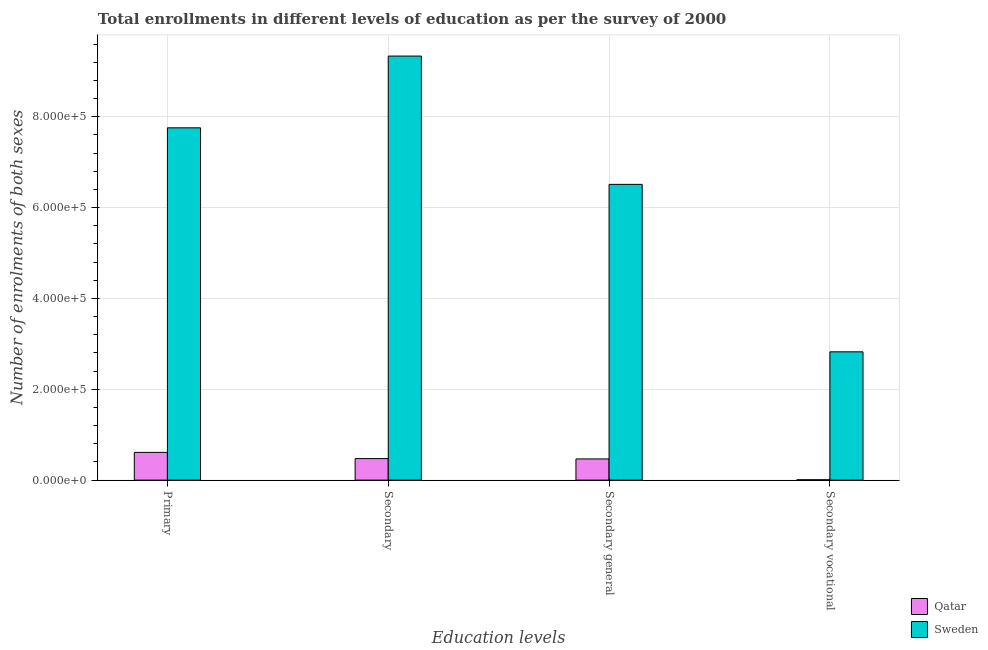How many different coloured bars are there?
Your response must be concise. 2. How many bars are there on the 4th tick from the left?
Give a very brief answer. 2. What is the label of the 2nd group of bars from the left?
Give a very brief answer. Secondary. What is the number of enrolments in primary education in Qatar?
Provide a short and direct response. 6.11e+04. Across all countries, what is the maximum number of enrolments in secondary vocational education?
Your answer should be compact. 2.82e+05. Across all countries, what is the minimum number of enrolments in secondary education?
Your answer should be very brief. 4.74e+04. In which country was the number of enrolments in secondary vocational education maximum?
Your response must be concise. Sweden. In which country was the number of enrolments in primary education minimum?
Offer a very short reply. Qatar. What is the total number of enrolments in secondary general education in the graph?
Your answer should be compact. 6.98e+05. What is the difference between the number of enrolments in primary education in Qatar and that in Sweden?
Provide a succinct answer. -7.15e+05. What is the difference between the number of enrolments in secondary education in Qatar and the number of enrolments in secondary general education in Sweden?
Make the answer very short. -6.04e+05. What is the average number of enrolments in secondary general education per country?
Provide a succinct answer. 3.49e+05. What is the difference between the number of enrolments in secondary vocational education and number of enrolments in primary education in Sweden?
Your answer should be very brief. -4.93e+05. What is the ratio of the number of enrolments in secondary vocational education in Sweden to that in Qatar?
Make the answer very short. 371.68. Is the number of enrolments in primary education in Sweden less than that in Qatar?
Your response must be concise. No. Is the difference between the number of enrolments in secondary vocational education in Qatar and Sweden greater than the difference between the number of enrolments in primary education in Qatar and Sweden?
Your answer should be compact. Yes. What is the difference between the highest and the second highest number of enrolments in primary education?
Provide a succinct answer. 7.15e+05. What is the difference between the highest and the lowest number of enrolments in secondary general education?
Offer a terse response. 6.05e+05. Is it the case that in every country, the sum of the number of enrolments in primary education and number of enrolments in secondary education is greater than the number of enrolments in secondary general education?
Ensure brevity in your answer.  Yes. Are all the bars in the graph horizontal?
Make the answer very short. No. What is the difference between two consecutive major ticks on the Y-axis?
Your answer should be very brief. 2.00e+05. Does the graph contain grids?
Your response must be concise. Yes. How many legend labels are there?
Offer a terse response. 2. How are the legend labels stacked?
Ensure brevity in your answer.  Vertical. What is the title of the graph?
Provide a succinct answer. Total enrollments in different levels of education as per the survey of 2000. Does "Caribbean small states" appear as one of the legend labels in the graph?
Your answer should be very brief. No. What is the label or title of the X-axis?
Keep it short and to the point. Education levels. What is the label or title of the Y-axis?
Give a very brief answer. Number of enrolments of both sexes. What is the Number of enrolments of both sexes in Qatar in Primary?
Your answer should be compact. 6.11e+04. What is the Number of enrolments of both sexes of Sweden in Primary?
Provide a short and direct response. 7.76e+05. What is the Number of enrolments of both sexes in Qatar in Secondary?
Offer a very short reply. 4.74e+04. What is the Number of enrolments of both sexes of Sweden in Secondary?
Your answer should be compact. 9.34e+05. What is the Number of enrolments of both sexes of Qatar in Secondary general?
Provide a short and direct response. 4.67e+04. What is the Number of enrolments of both sexes of Sweden in Secondary general?
Give a very brief answer. 6.51e+05. What is the Number of enrolments of both sexes of Qatar in Secondary vocational?
Offer a very short reply. 760. What is the Number of enrolments of both sexes of Sweden in Secondary vocational?
Keep it short and to the point. 2.82e+05. Across all Education levels, what is the maximum Number of enrolments of both sexes of Qatar?
Ensure brevity in your answer.  6.11e+04. Across all Education levels, what is the maximum Number of enrolments of both sexes in Sweden?
Your answer should be very brief. 9.34e+05. Across all Education levels, what is the minimum Number of enrolments of both sexes in Qatar?
Your response must be concise. 760. Across all Education levels, what is the minimum Number of enrolments of both sexes in Sweden?
Provide a succinct answer. 2.82e+05. What is the total Number of enrolments of both sexes in Qatar in the graph?
Provide a succinct answer. 1.56e+05. What is the total Number of enrolments of both sexes in Sweden in the graph?
Provide a short and direct response. 2.64e+06. What is the difference between the Number of enrolments of both sexes in Qatar in Primary and that in Secondary?
Your answer should be very brief. 1.37e+04. What is the difference between the Number of enrolments of both sexes in Sweden in Primary and that in Secondary?
Make the answer very short. -1.58e+05. What is the difference between the Number of enrolments of both sexes of Qatar in Primary and that in Secondary general?
Make the answer very short. 1.44e+04. What is the difference between the Number of enrolments of both sexes in Sweden in Primary and that in Secondary general?
Offer a very short reply. 1.25e+05. What is the difference between the Number of enrolments of both sexes in Qatar in Primary and that in Secondary vocational?
Provide a succinct answer. 6.03e+04. What is the difference between the Number of enrolments of both sexes in Sweden in Primary and that in Secondary vocational?
Keep it short and to the point. 4.93e+05. What is the difference between the Number of enrolments of both sexes of Qatar in Secondary and that in Secondary general?
Provide a short and direct response. 760. What is the difference between the Number of enrolments of both sexes of Sweden in Secondary and that in Secondary general?
Your response must be concise. 2.82e+05. What is the difference between the Number of enrolments of both sexes in Qatar in Secondary and that in Secondary vocational?
Keep it short and to the point. 4.67e+04. What is the difference between the Number of enrolments of both sexes in Sweden in Secondary and that in Secondary vocational?
Provide a succinct answer. 6.51e+05. What is the difference between the Number of enrolments of both sexes in Qatar in Secondary general and that in Secondary vocational?
Ensure brevity in your answer.  4.59e+04. What is the difference between the Number of enrolments of both sexes of Sweden in Secondary general and that in Secondary vocational?
Provide a succinct answer. 3.69e+05. What is the difference between the Number of enrolments of both sexes in Qatar in Primary and the Number of enrolments of both sexes in Sweden in Secondary?
Provide a succinct answer. -8.73e+05. What is the difference between the Number of enrolments of both sexes of Qatar in Primary and the Number of enrolments of both sexes of Sweden in Secondary general?
Your response must be concise. -5.90e+05. What is the difference between the Number of enrolments of both sexes in Qatar in Primary and the Number of enrolments of both sexes in Sweden in Secondary vocational?
Offer a very short reply. -2.21e+05. What is the difference between the Number of enrolments of both sexes of Qatar in Secondary and the Number of enrolments of both sexes of Sweden in Secondary general?
Your response must be concise. -6.04e+05. What is the difference between the Number of enrolments of both sexes in Qatar in Secondary and the Number of enrolments of both sexes in Sweden in Secondary vocational?
Provide a succinct answer. -2.35e+05. What is the difference between the Number of enrolments of both sexes of Qatar in Secondary general and the Number of enrolments of both sexes of Sweden in Secondary vocational?
Give a very brief answer. -2.36e+05. What is the average Number of enrolments of both sexes in Qatar per Education levels?
Ensure brevity in your answer.  3.90e+04. What is the average Number of enrolments of both sexes of Sweden per Education levels?
Provide a succinct answer. 6.61e+05. What is the difference between the Number of enrolments of both sexes in Qatar and Number of enrolments of both sexes in Sweden in Primary?
Your answer should be very brief. -7.15e+05. What is the difference between the Number of enrolments of both sexes in Qatar and Number of enrolments of both sexes in Sweden in Secondary?
Provide a succinct answer. -8.86e+05. What is the difference between the Number of enrolments of both sexes of Qatar and Number of enrolments of both sexes of Sweden in Secondary general?
Offer a very short reply. -6.05e+05. What is the difference between the Number of enrolments of both sexes in Qatar and Number of enrolments of both sexes in Sweden in Secondary vocational?
Offer a very short reply. -2.82e+05. What is the ratio of the Number of enrolments of both sexes in Qatar in Primary to that in Secondary?
Your answer should be compact. 1.29. What is the ratio of the Number of enrolments of both sexes in Sweden in Primary to that in Secondary?
Your answer should be compact. 0.83. What is the ratio of the Number of enrolments of both sexes in Qatar in Primary to that in Secondary general?
Your answer should be very brief. 1.31. What is the ratio of the Number of enrolments of both sexes of Sweden in Primary to that in Secondary general?
Your response must be concise. 1.19. What is the ratio of the Number of enrolments of both sexes in Qatar in Primary to that in Secondary vocational?
Offer a very short reply. 80.35. What is the ratio of the Number of enrolments of both sexes in Sweden in Primary to that in Secondary vocational?
Give a very brief answer. 2.75. What is the ratio of the Number of enrolments of both sexes in Qatar in Secondary to that in Secondary general?
Offer a terse response. 1.02. What is the ratio of the Number of enrolments of both sexes in Sweden in Secondary to that in Secondary general?
Your answer should be compact. 1.43. What is the ratio of the Number of enrolments of both sexes of Qatar in Secondary to that in Secondary vocational?
Your answer should be very brief. 62.39. What is the ratio of the Number of enrolments of both sexes of Sweden in Secondary to that in Secondary vocational?
Your response must be concise. 3.31. What is the ratio of the Number of enrolments of both sexes of Qatar in Secondary general to that in Secondary vocational?
Provide a succinct answer. 61.39. What is the ratio of the Number of enrolments of both sexes in Sweden in Secondary general to that in Secondary vocational?
Your response must be concise. 2.31. What is the difference between the highest and the second highest Number of enrolments of both sexes in Qatar?
Your answer should be very brief. 1.37e+04. What is the difference between the highest and the second highest Number of enrolments of both sexes of Sweden?
Offer a very short reply. 1.58e+05. What is the difference between the highest and the lowest Number of enrolments of both sexes in Qatar?
Make the answer very short. 6.03e+04. What is the difference between the highest and the lowest Number of enrolments of both sexes of Sweden?
Keep it short and to the point. 6.51e+05. 